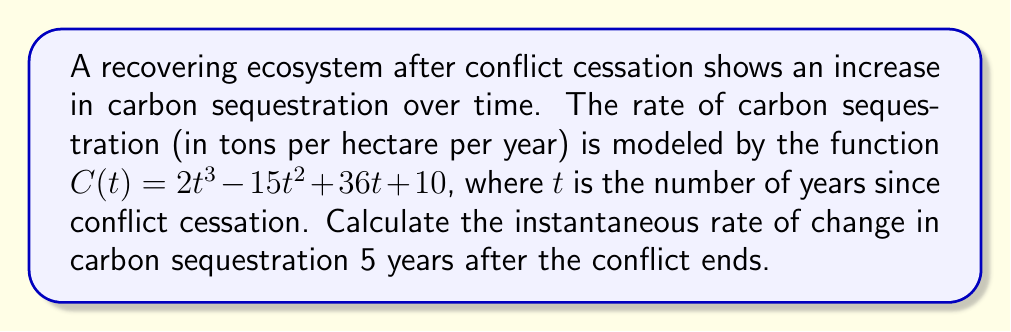Teach me how to tackle this problem. To find the instantaneous rate of change in carbon sequestration 5 years after the conflict ends, we need to calculate the derivative of the given function $C(t)$ and then evaluate it at $t = 5$.

Step 1: Find the derivative of $C(t)$.
$C(t) = 2t^3 - 15t^2 + 36t + 10$
$C'(t) = \frac{d}{dt}(2t^3 - 15t^2 + 36t + 10)$
$C'(t) = 6t^2 - 30t + 36$

Step 2: Evaluate $C'(t)$ at $t = 5$.
$C'(5) = 6(5)^2 - 30(5) + 36$
$C'(5) = 6(25) - 150 + 36$
$C'(5) = 150 - 150 + 36$
$C'(5) = 36$

Therefore, the instantaneous rate of change in carbon sequestration 5 years after the conflict ends is 36 tons per hectare per year.
Answer: 36 tons per hectare per year 